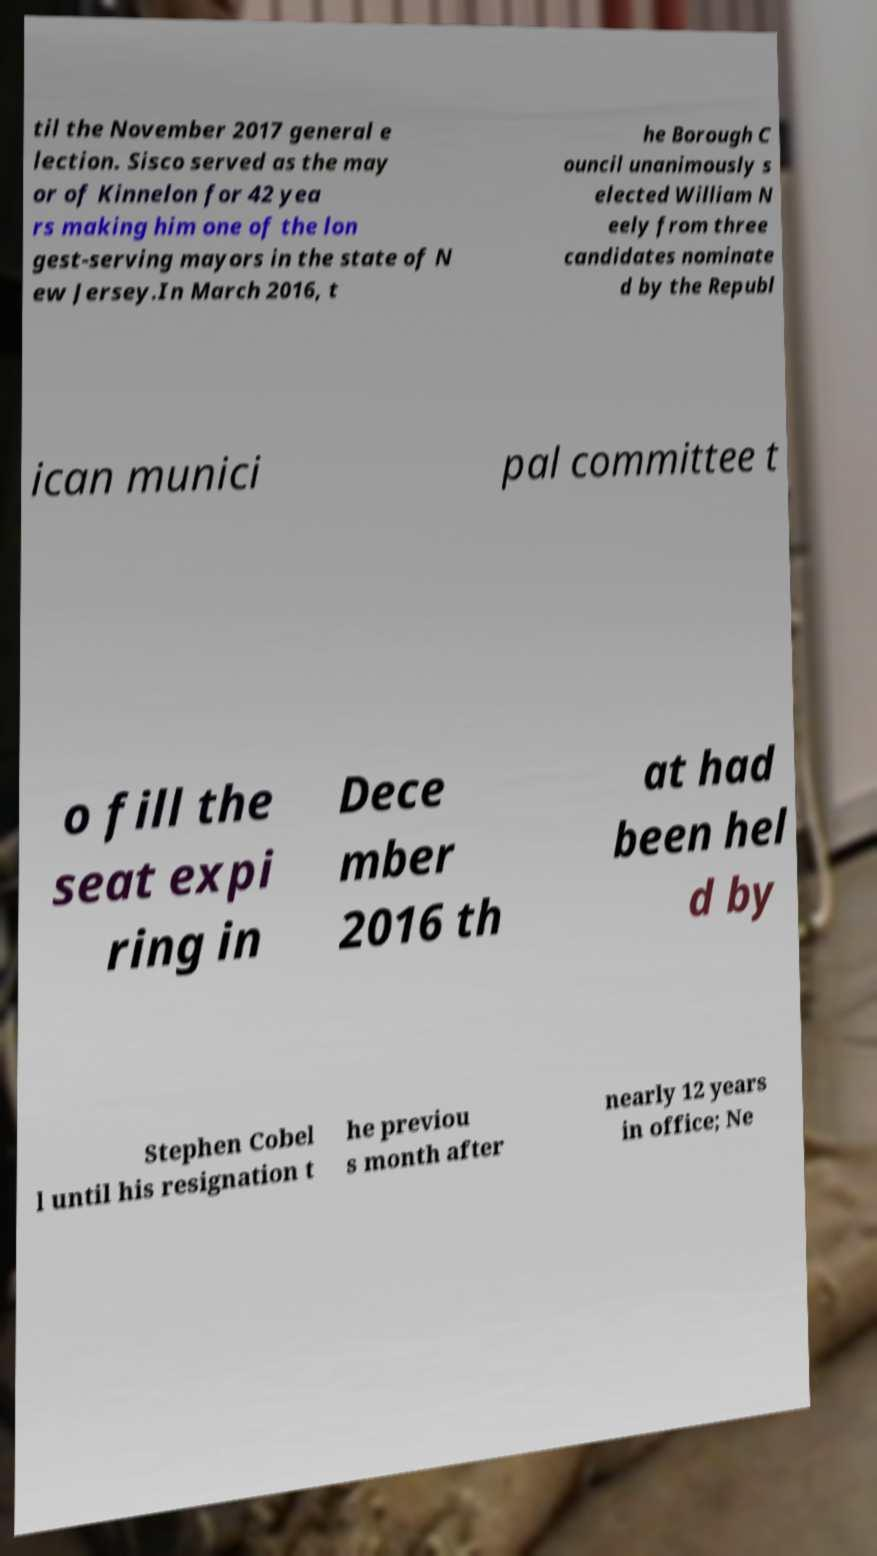What messages or text are displayed in this image? I need them in a readable, typed format. til the November 2017 general e lection. Sisco served as the may or of Kinnelon for 42 yea rs making him one of the lon gest-serving mayors in the state of N ew Jersey.In March 2016, t he Borough C ouncil unanimously s elected William N eely from three candidates nominate d by the Republ ican munici pal committee t o fill the seat expi ring in Dece mber 2016 th at had been hel d by Stephen Cobel l until his resignation t he previou s month after nearly 12 years in office; Ne 